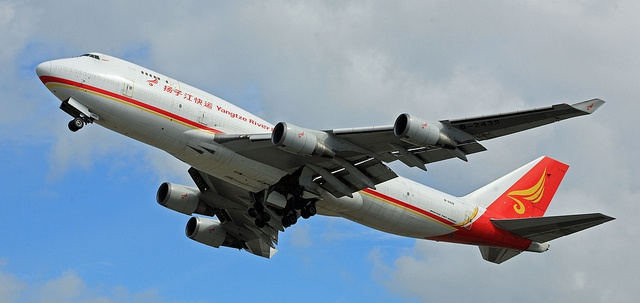Describe the objects in this image and their specific colors. I can see a airplane in darkgray, black, gray, and lightgray tones in this image. 